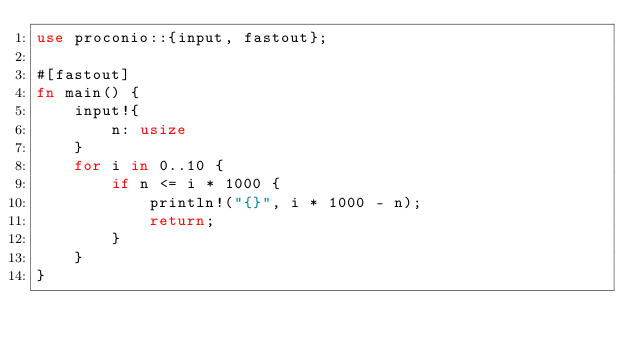Convert code to text. <code><loc_0><loc_0><loc_500><loc_500><_Rust_>use proconio::{input, fastout};

#[fastout]
fn main() {
    input!{
        n: usize
    }
    for i in 0..10 {
        if n <= i * 1000 {
            println!("{}", i * 1000 - n);
            return;
        }
    }
}
</code> 